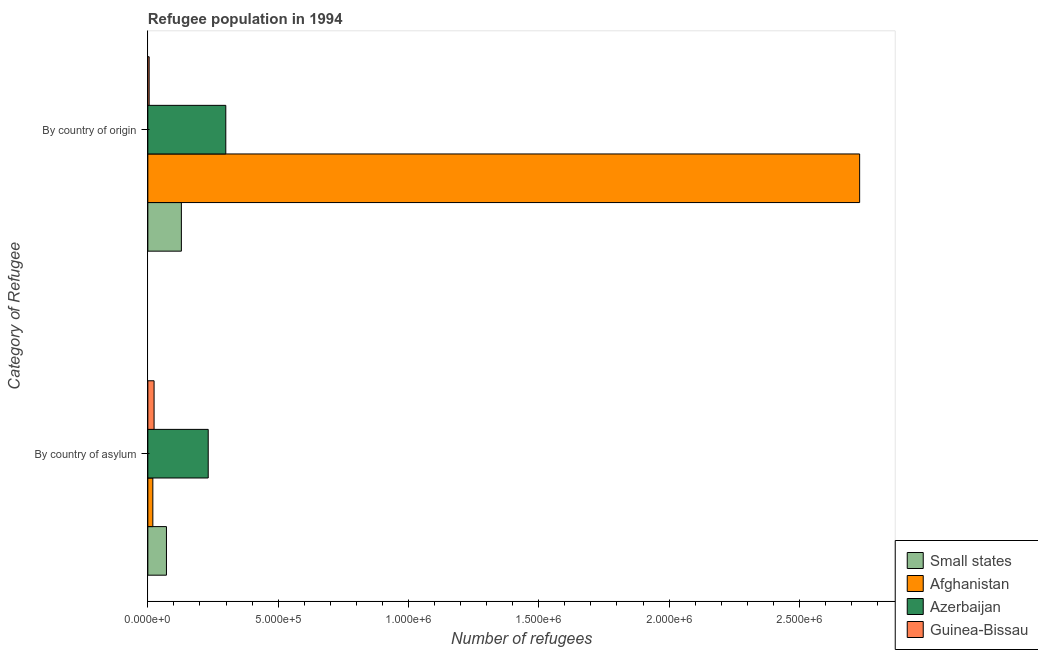How many different coloured bars are there?
Make the answer very short. 4. How many bars are there on the 2nd tick from the bottom?
Offer a terse response. 4. What is the label of the 2nd group of bars from the top?
Offer a terse response. By country of asylum. What is the number of refugees by country of origin in Guinea-Bissau?
Your answer should be compact. 5015. Across all countries, what is the maximum number of refugees by country of asylum?
Offer a very short reply. 2.32e+05. Across all countries, what is the minimum number of refugees by country of origin?
Your response must be concise. 5015. In which country was the number of refugees by country of origin maximum?
Your answer should be very brief. Afghanistan. In which country was the number of refugees by country of asylum minimum?
Your answer should be compact. Afghanistan. What is the total number of refugees by country of origin in the graph?
Make the answer very short. 3.16e+06. What is the difference between the number of refugees by country of origin in Afghanistan and that in Guinea-Bissau?
Provide a short and direct response. 2.73e+06. What is the difference between the number of refugees by country of origin in Azerbaijan and the number of refugees by country of asylum in Small states?
Offer a very short reply. 2.28e+05. What is the average number of refugees by country of origin per country?
Your response must be concise. 7.91e+05. What is the difference between the number of refugees by country of asylum and number of refugees by country of origin in Afghanistan?
Your answer should be very brief. -2.71e+06. What is the ratio of the number of refugees by country of asylum in Small states to that in Afghanistan?
Make the answer very short. 3.73. What does the 2nd bar from the top in By country of asylum represents?
Your answer should be very brief. Azerbaijan. What does the 1st bar from the bottom in By country of origin represents?
Your answer should be very brief. Small states. Are the values on the major ticks of X-axis written in scientific E-notation?
Give a very brief answer. Yes. What is the title of the graph?
Your answer should be compact. Refugee population in 1994. What is the label or title of the X-axis?
Make the answer very short. Number of refugees. What is the label or title of the Y-axis?
Keep it short and to the point. Category of Refugee. What is the Number of refugees in Small states in By country of asylum?
Offer a terse response. 7.14e+04. What is the Number of refugees in Afghanistan in By country of asylum?
Give a very brief answer. 1.91e+04. What is the Number of refugees in Azerbaijan in By country of asylum?
Make the answer very short. 2.32e+05. What is the Number of refugees in Guinea-Bissau in By country of asylum?
Your response must be concise. 2.39e+04. What is the Number of refugees of Small states in By country of origin?
Provide a succinct answer. 1.29e+05. What is the Number of refugees of Afghanistan in By country of origin?
Make the answer very short. 2.73e+06. What is the Number of refugees of Azerbaijan in By country of origin?
Provide a succinct answer. 2.99e+05. What is the Number of refugees in Guinea-Bissau in By country of origin?
Ensure brevity in your answer.  5015. Across all Category of Refugee, what is the maximum Number of refugees in Small states?
Your response must be concise. 1.29e+05. Across all Category of Refugee, what is the maximum Number of refugees in Afghanistan?
Your response must be concise. 2.73e+06. Across all Category of Refugee, what is the maximum Number of refugees in Azerbaijan?
Give a very brief answer. 2.99e+05. Across all Category of Refugee, what is the maximum Number of refugees in Guinea-Bissau?
Give a very brief answer. 2.39e+04. Across all Category of Refugee, what is the minimum Number of refugees of Small states?
Your answer should be very brief. 7.14e+04. Across all Category of Refugee, what is the minimum Number of refugees in Afghanistan?
Give a very brief answer. 1.91e+04. Across all Category of Refugee, what is the minimum Number of refugees of Azerbaijan?
Make the answer very short. 2.32e+05. Across all Category of Refugee, what is the minimum Number of refugees in Guinea-Bissau?
Make the answer very short. 5015. What is the total Number of refugees of Small states in the graph?
Provide a succinct answer. 2.00e+05. What is the total Number of refugees in Afghanistan in the graph?
Offer a very short reply. 2.75e+06. What is the total Number of refugees in Azerbaijan in the graph?
Your answer should be compact. 5.31e+05. What is the total Number of refugees of Guinea-Bissau in the graph?
Your answer should be compact. 2.89e+04. What is the difference between the Number of refugees in Small states in By country of asylum and that in By country of origin?
Keep it short and to the point. -5.72e+04. What is the difference between the Number of refugees in Afghanistan in By country of asylum and that in By country of origin?
Give a very brief answer. -2.71e+06. What is the difference between the Number of refugees in Azerbaijan in By country of asylum and that in By country of origin?
Offer a very short reply. -6.75e+04. What is the difference between the Number of refugees of Guinea-Bissau in By country of asylum and that in By country of origin?
Make the answer very short. 1.89e+04. What is the difference between the Number of refugees of Small states in By country of asylum and the Number of refugees of Afghanistan in By country of origin?
Your response must be concise. -2.66e+06. What is the difference between the Number of refugees in Small states in By country of asylum and the Number of refugees in Azerbaijan in By country of origin?
Your answer should be very brief. -2.28e+05. What is the difference between the Number of refugees of Small states in By country of asylum and the Number of refugees of Guinea-Bissau in By country of origin?
Provide a succinct answer. 6.64e+04. What is the difference between the Number of refugees of Afghanistan in By country of asylum and the Number of refugees of Azerbaijan in By country of origin?
Provide a short and direct response. -2.80e+05. What is the difference between the Number of refugees in Afghanistan in By country of asylum and the Number of refugees in Guinea-Bissau in By country of origin?
Your response must be concise. 1.41e+04. What is the difference between the Number of refugees of Azerbaijan in By country of asylum and the Number of refugees of Guinea-Bissau in By country of origin?
Offer a terse response. 2.27e+05. What is the average Number of refugees of Small states per Category of Refugee?
Offer a terse response. 1.00e+05. What is the average Number of refugees in Afghanistan per Category of Refugee?
Your answer should be very brief. 1.38e+06. What is the average Number of refugees of Azerbaijan per Category of Refugee?
Offer a very short reply. 2.65e+05. What is the average Number of refugees of Guinea-Bissau per Category of Refugee?
Your answer should be compact. 1.45e+04. What is the difference between the Number of refugees in Small states and Number of refugees in Afghanistan in By country of asylum?
Offer a very short reply. 5.23e+04. What is the difference between the Number of refugees of Small states and Number of refugees of Azerbaijan in By country of asylum?
Your answer should be compact. -1.60e+05. What is the difference between the Number of refugees of Small states and Number of refugees of Guinea-Bissau in By country of asylum?
Your answer should be very brief. 4.75e+04. What is the difference between the Number of refugees in Afghanistan and Number of refugees in Azerbaijan in By country of asylum?
Make the answer very short. -2.13e+05. What is the difference between the Number of refugees of Afghanistan and Number of refugees of Guinea-Bissau in By country of asylum?
Keep it short and to the point. -4778. What is the difference between the Number of refugees of Azerbaijan and Number of refugees of Guinea-Bissau in By country of asylum?
Your response must be concise. 2.08e+05. What is the difference between the Number of refugees of Small states and Number of refugees of Afghanistan in By country of origin?
Give a very brief answer. -2.60e+06. What is the difference between the Number of refugees in Small states and Number of refugees in Azerbaijan in By country of origin?
Offer a terse response. -1.70e+05. What is the difference between the Number of refugees of Small states and Number of refugees of Guinea-Bissau in By country of origin?
Offer a terse response. 1.24e+05. What is the difference between the Number of refugees of Afghanistan and Number of refugees of Azerbaijan in By country of origin?
Your answer should be compact. 2.43e+06. What is the difference between the Number of refugees of Afghanistan and Number of refugees of Guinea-Bissau in By country of origin?
Give a very brief answer. 2.73e+06. What is the difference between the Number of refugees of Azerbaijan and Number of refugees of Guinea-Bissau in By country of origin?
Provide a short and direct response. 2.94e+05. What is the ratio of the Number of refugees of Small states in By country of asylum to that in By country of origin?
Your answer should be very brief. 0.56. What is the ratio of the Number of refugees of Afghanistan in By country of asylum to that in By country of origin?
Keep it short and to the point. 0.01. What is the ratio of the Number of refugees of Azerbaijan in By country of asylum to that in By country of origin?
Make the answer very short. 0.77. What is the ratio of the Number of refugees in Guinea-Bissau in By country of asylum to that in By country of origin?
Your answer should be very brief. 4.77. What is the difference between the highest and the second highest Number of refugees of Small states?
Your answer should be compact. 5.72e+04. What is the difference between the highest and the second highest Number of refugees in Afghanistan?
Make the answer very short. 2.71e+06. What is the difference between the highest and the second highest Number of refugees in Azerbaijan?
Your response must be concise. 6.75e+04. What is the difference between the highest and the second highest Number of refugees of Guinea-Bissau?
Your response must be concise. 1.89e+04. What is the difference between the highest and the lowest Number of refugees in Small states?
Provide a short and direct response. 5.72e+04. What is the difference between the highest and the lowest Number of refugees of Afghanistan?
Provide a succinct answer. 2.71e+06. What is the difference between the highest and the lowest Number of refugees of Azerbaijan?
Offer a very short reply. 6.75e+04. What is the difference between the highest and the lowest Number of refugees in Guinea-Bissau?
Your response must be concise. 1.89e+04. 